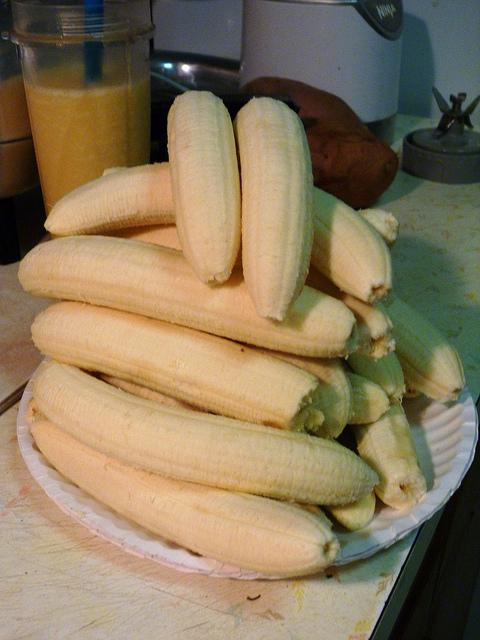What happened to these bananas?

Choices:
A) fried
B) peeled
C) baked
D) chopped peeled 